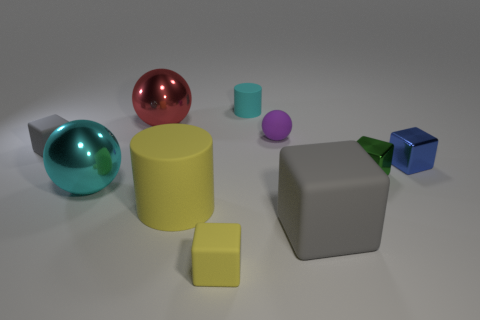Subtract all metallic balls. How many balls are left? 1 Subtract all cylinders. How many objects are left? 8 Subtract 5 cubes. How many cubes are left? 0 Subtract all purple blocks. Subtract all cyan balls. How many blocks are left? 5 Subtract all blue balls. How many yellow cylinders are left? 1 Subtract all blue rubber objects. Subtract all small blue objects. How many objects are left? 9 Add 7 cyan matte things. How many cyan matte things are left? 8 Add 8 green shiny objects. How many green shiny objects exist? 9 Subtract all green cubes. How many cubes are left? 4 Subtract 0 purple cubes. How many objects are left? 10 